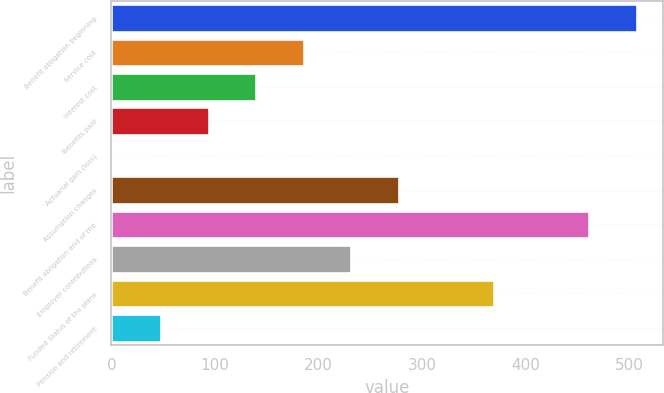Convert chart. <chart><loc_0><loc_0><loc_500><loc_500><bar_chart><fcel>Benefit obligation beginning<fcel>Service cost<fcel>Interest cost<fcel>Benefits paid<fcel>Actuarial gain (loss)<fcel>Assumption changes<fcel>Benefit obligation end of the<fcel>Employer contributions<fcel>Funded Status of the plans<fcel>Pension and retirement<nl><fcel>507.79<fcel>185.86<fcel>139.87<fcel>93.88<fcel>1.9<fcel>277.84<fcel>461.8<fcel>231.85<fcel>369.82<fcel>47.89<nl></chart> 